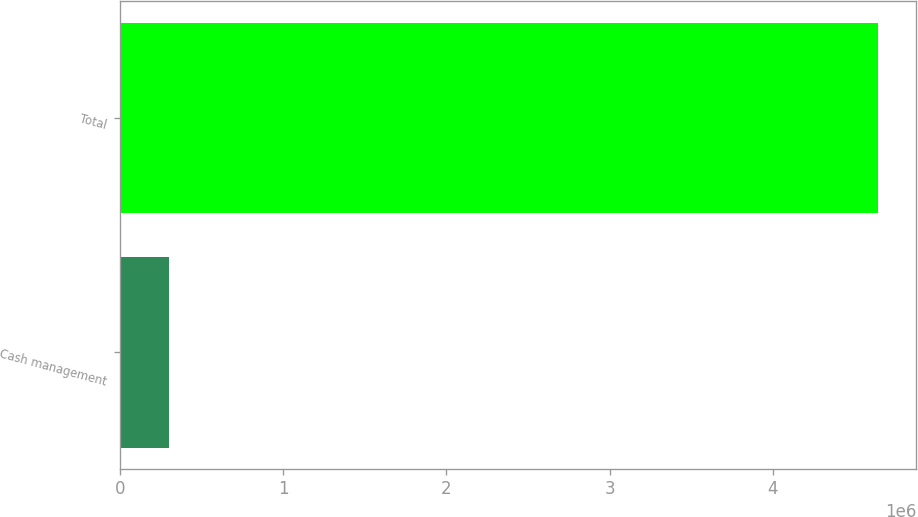Convert chart to OTSL. <chart><loc_0><loc_0><loc_500><loc_500><bar_chart><fcel>Cash management<fcel>Total<nl><fcel>299884<fcel>4.64541e+06<nl></chart> 